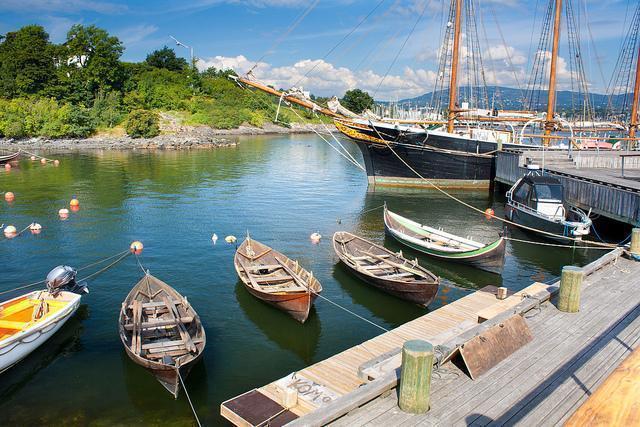What is the color of the sail boat?
From the following set of four choices, select the accurate answer to respond to the question.
Options: Red, orange, white, black. Black. 